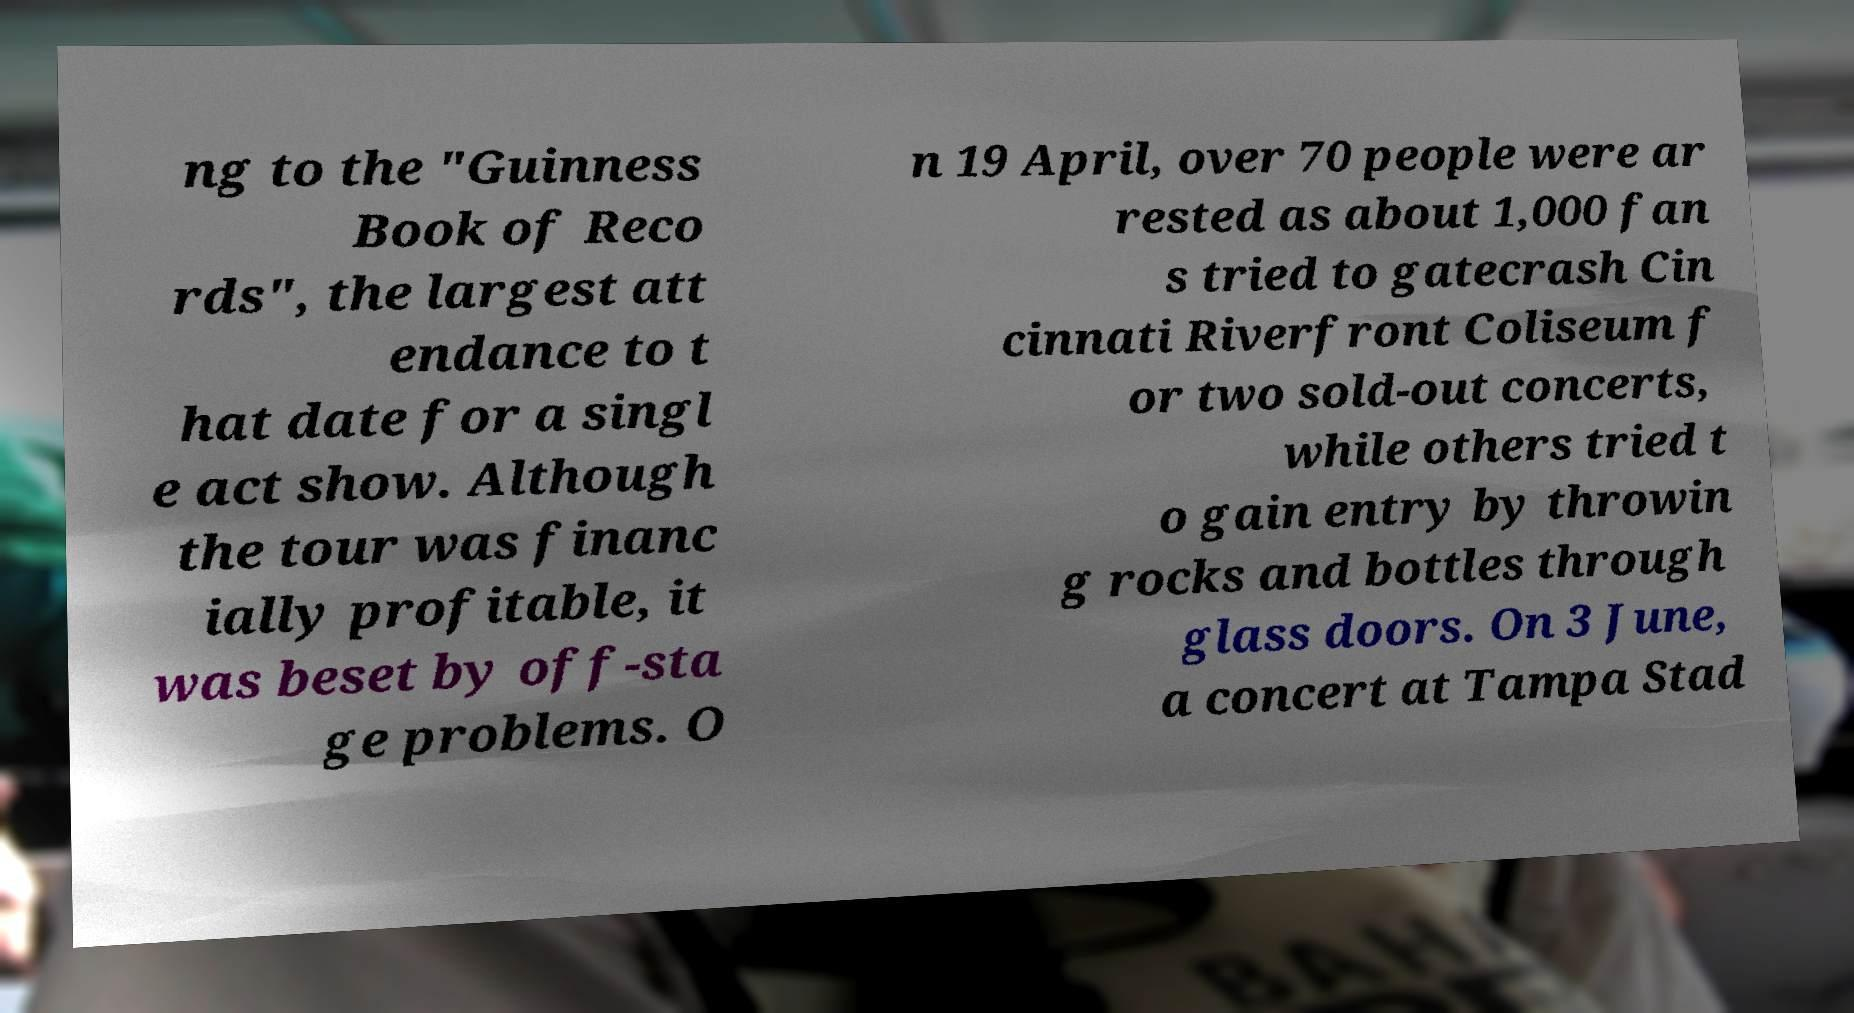Please identify and transcribe the text found in this image. ng to the "Guinness Book of Reco rds", the largest att endance to t hat date for a singl e act show. Although the tour was financ ially profitable, it was beset by off-sta ge problems. O n 19 April, over 70 people were ar rested as about 1,000 fan s tried to gatecrash Cin cinnati Riverfront Coliseum f or two sold-out concerts, while others tried t o gain entry by throwin g rocks and bottles through glass doors. On 3 June, a concert at Tampa Stad 